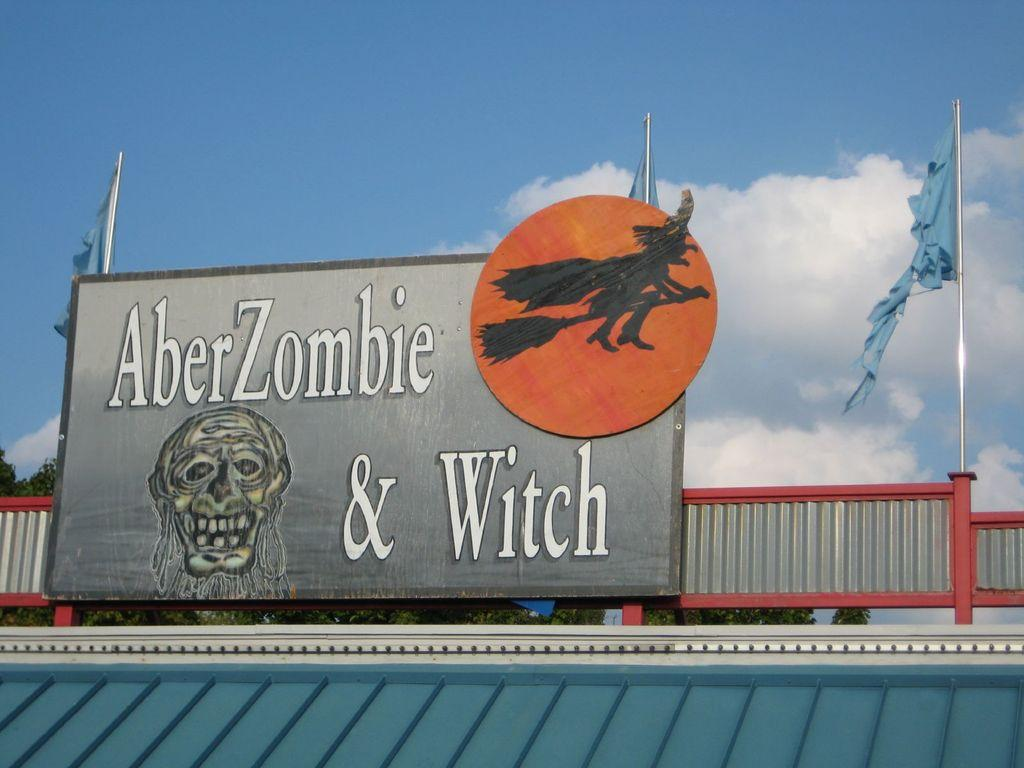<image>
Describe the image concisely. A sign states, "AberZombie and Witch" with flage on either corner. 